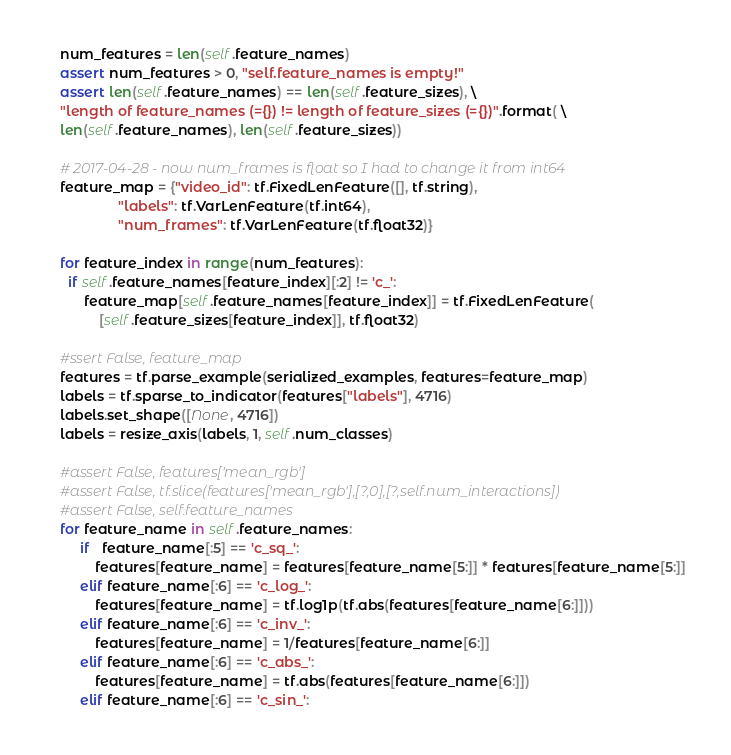Convert code to text. <code><loc_0><loc_0><loc_500><loc_500><_Python_>    num_features = len(self.feature_names)
    assert num_features > 0, "self.feature_names is empty!"
    assert len(self.feature_names) == len(self.feature_sizes), \
    "length of feature_names (={}) != length of feature_sizes (={})".format( \
    len(self.feature_names), len(self.feature_sizes))

    # 2017-04-28 - now num_frames is float so I had to change it from int64
    feature_map = {"video_id": tf.FixedLenFeature([], tf.string),
                   "labels": tf.VarLenFeature(tf.int64), 
                   "num_frames": tf.VarLenFeature(tf.float32)}
    
    for feature_index in range(num_features):
      if self.feature_names[feature_index][:2] != 'c_':
          feature_map[self.feature_names[feature_index]] = tf.FixedLenFeature(
              [self.feature_sizes[feature_index]], tf.float32)

    #ssert False, feature_map
    features = tf.parse_example(serialized_examples, features=feature_map)
    labels = tf.sparse_to_indicator(features["labels"], 4716)
    labels.set_shape([None, 4716])
    labels = resize_axis(labels, 1, self.num_classes)

    #assert False, features['mean_rgb']
    #assert False, tf.slice(features['mean_rgb'],[?,0],[?,self.num_interactions])
    #assert False, self.feature_names
    for feature_name in self.feature_names:
         if   feature_name[:5] == 'c_sq_':
             features[feature_name] = features[feature_name[5:]] * features[feature_name[5:]]
         elif feature_name[:6] == 'c_log_':
             features[feature_name] = tf.log1p(tf.abs(features[feature_name[6:]]))
         elif feature_name[:6] == 'c_inv_':
             features[feature_name] = 1/features[feature_name[6:]]
         elif feature_name[:6] == 'c_abs_':
             features[feature_name] = tf.abs(features[feature_name[6:]])
         elif feature_name[:6] == 'c_sin_':</code> 